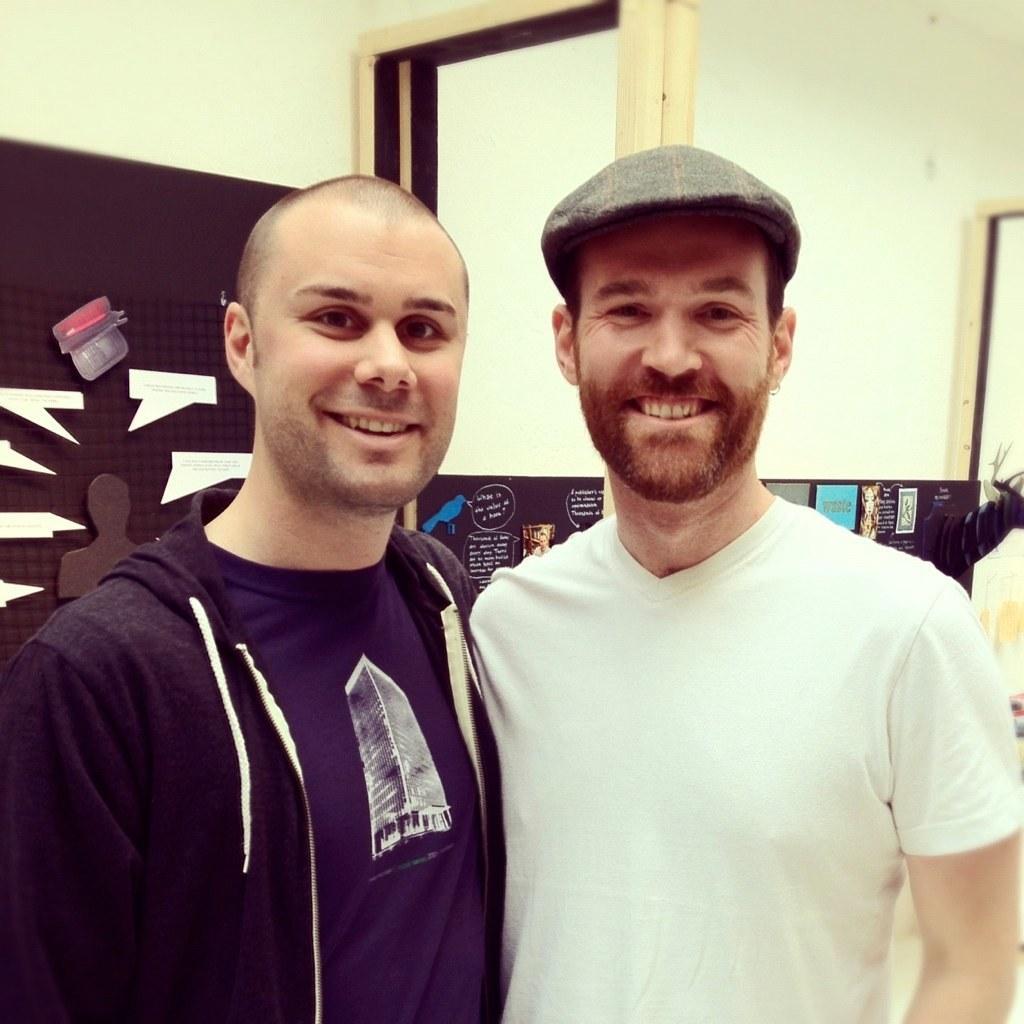Can you describe this image briefly? In this image I can see two men are standing and I can see smile on their faces. I can see one of them is wearing white t shirt, a cap and another one is wearing black colour dress. In the background I can see few boards and on these words I can see something is written. 